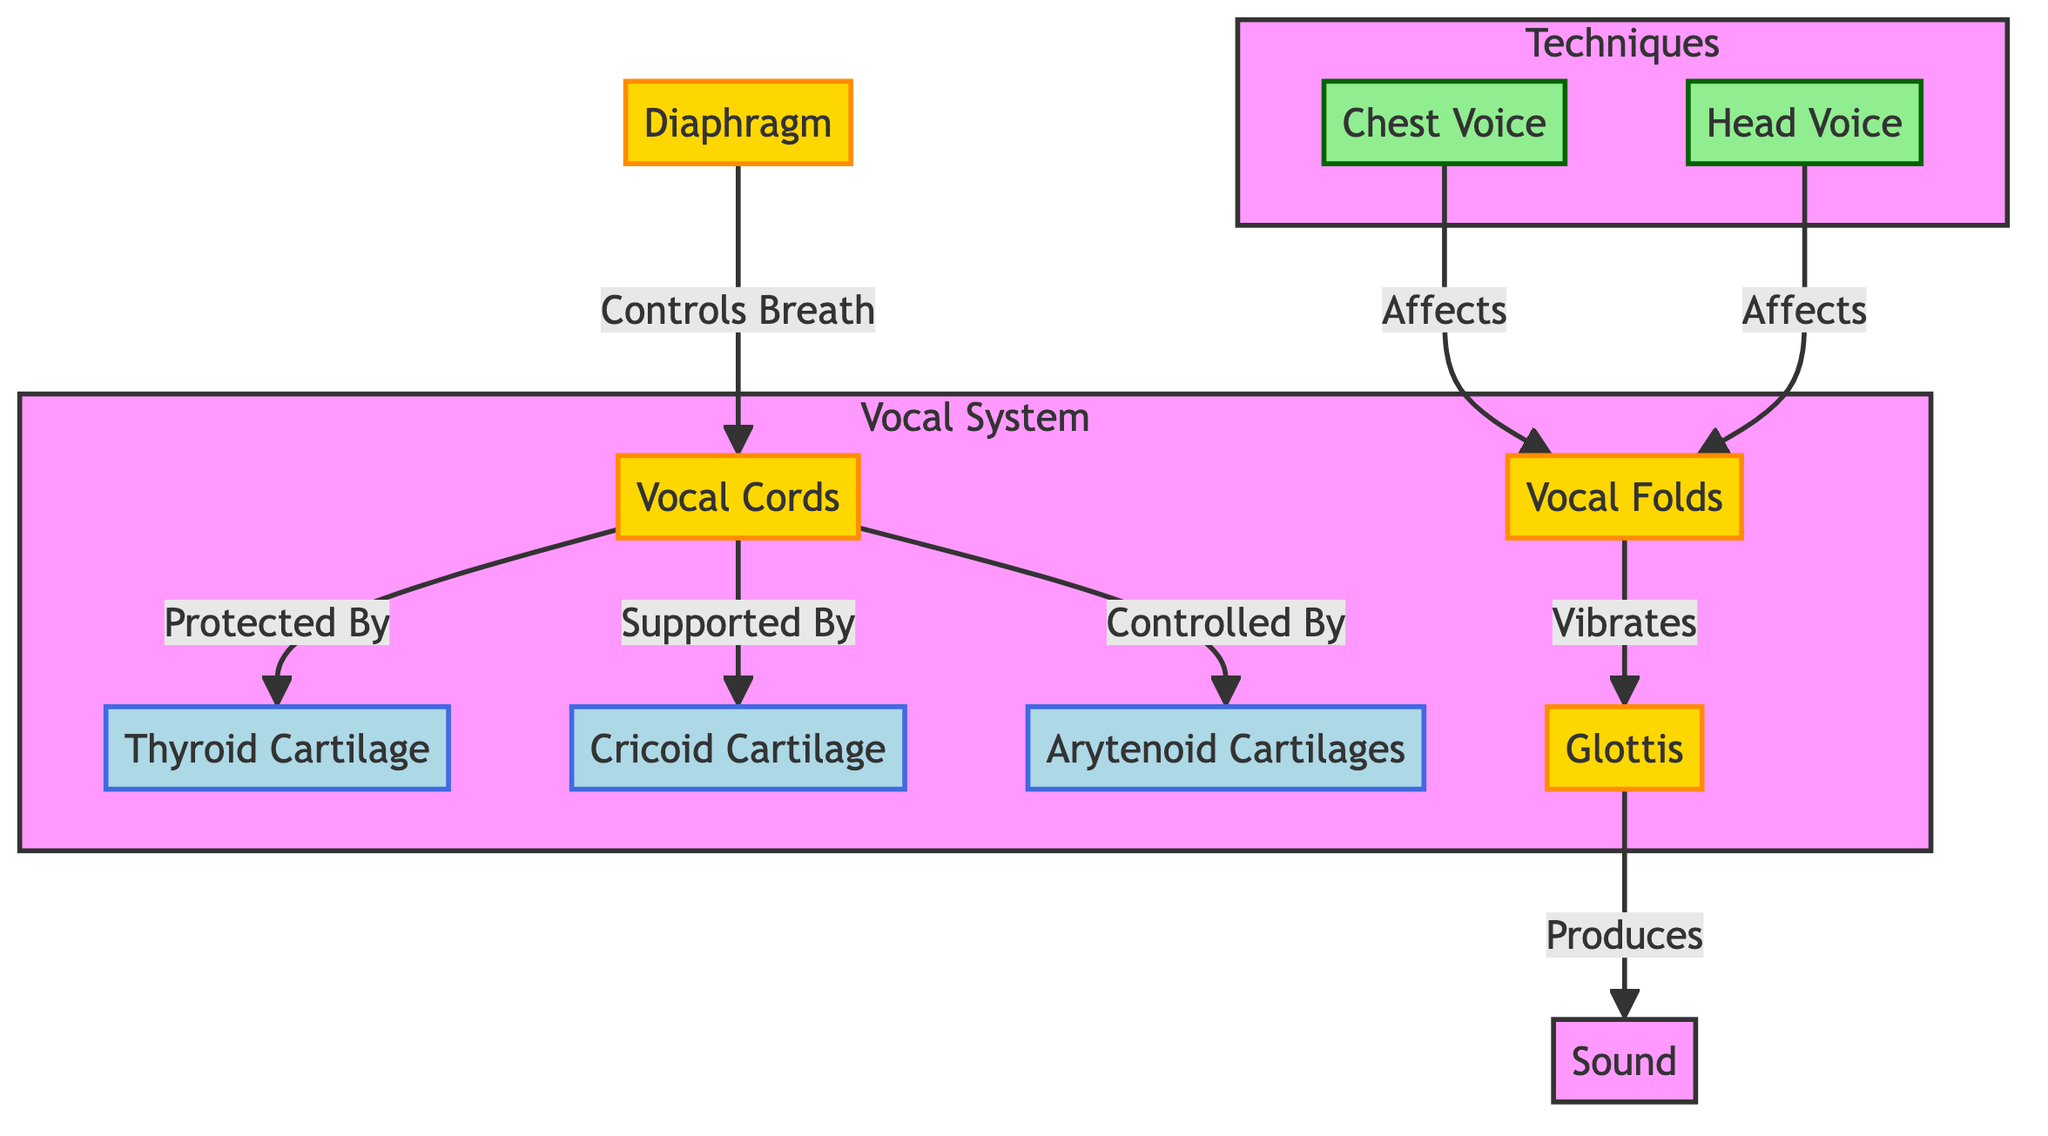What structures protect the vocal cords? The diagram indicates that the thyroid cartilage protects the vocal cords as shown by the arrow labeled "Protected By."
Answer: thyroid cartilage How many vocal techniques are shown in the diagram? The diagram features two techniques: chest voice and head voice, which are displayed in the Techniques subgraph.
Answer: 2 What organ controls breath for the vocal cords? According to the diagram, the diaphragm is indicated as controlling breath for the vocal cords, as shown by the arrow labeled "Controls Breath."
Answer: diaphragm Which vocal technique affects the vocal folds? The diagram indicates that both the chest voice and head voice affect the vocal folds, as each is connected to the vocal folds with the arrow labeled "Affects."
Answer: chest voice and head voice What structure vibrates to produce sound? The glottis is indicated in the diagram as the structure that vibrates to produce sound, as shown by the arrow labeled "Vibrates."
Answer: glottis What supports the vocal cords? The cricoid cartilage is shown in the diagram as supporting the vocal cords, indicated by the arrow labeled "Supported By."
Answer: cricoid cartilage Explain the relationship between the vocal folds and the glottis. The diagram shows that the vocal folds vibrate, leading to the production of sound at the glottis, as depicted by the arrows labeled "Vibrates" and "Produces." This connection indicates that the vocal folds create sound through their vibration, which resonates in the glottis.
Answer: Vocal folds vibrate glottis How do chest voice and head voice relate to vocal folds? The diagram illustrates that both chest voice and head voice are connected to the vocal folds through arrows, both labeled "Affects," indicating that both techniques influence the way vocal folds operate. This reflects how different singing techniques can alter the vocal fold activity and, consequently, the sound produced.
Answer: Affects vocal folds What is the total number of nodes in the diagram? The diagram contains a total of eight nodes, counting each structure and technique as nodes represented in the flowchart.
Answer: 8 